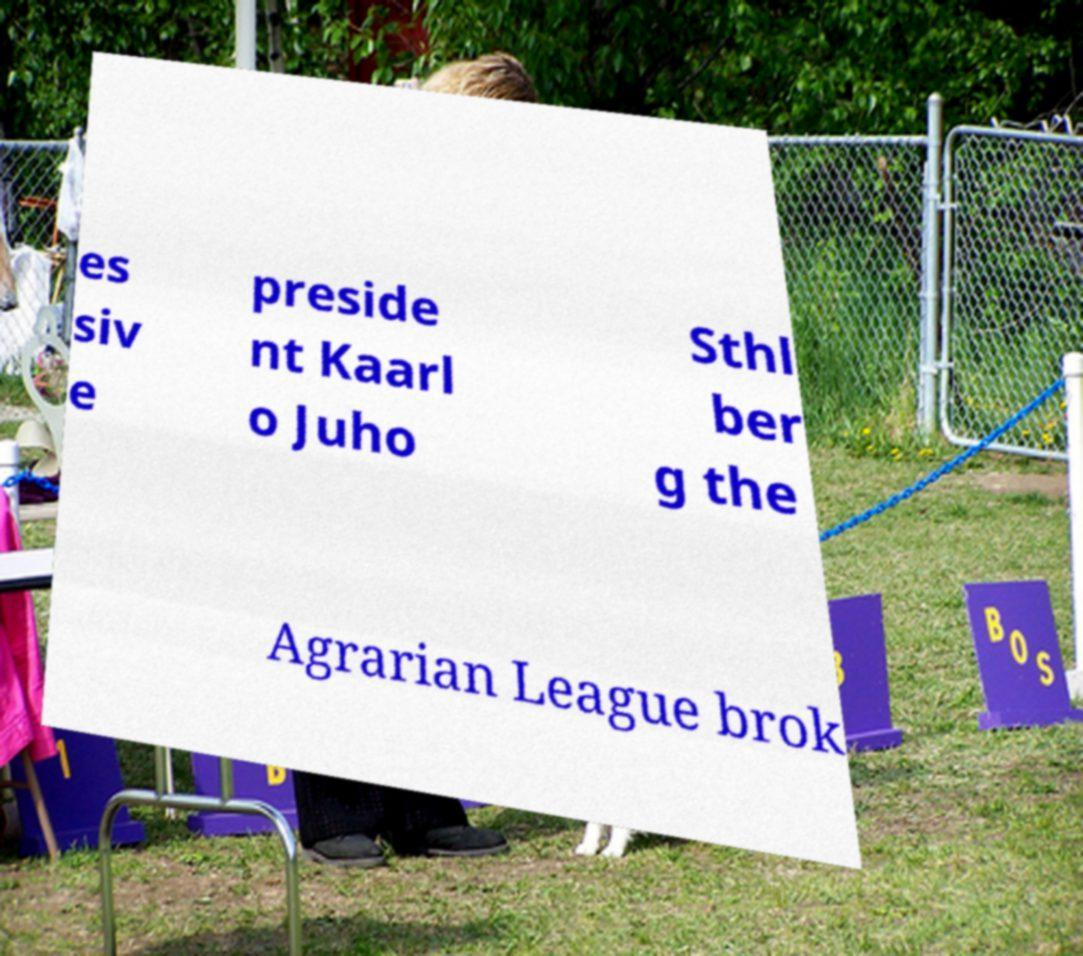Could you assist in decoding the text presented in this image and type it out clearly? es siv e preside nt Kaarl o Juho Sthl ber g the Agrarian League brok 